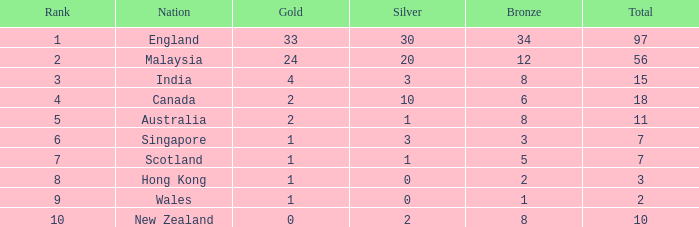Given that scotland has less than 7 medals in total, what is their tally of bronze medals? None. Would you be able to parse every entry in this table? {'header': ['Rank', 'Nation', 'Gold', 'Silver', 'Bronze', 'Total'], 'rows': [['1', 'England', '33', '30', '34', '97'], ['2', 'Malaysia', '24', '20', '12', '56'], ['3', 'India', '4', '3', '8', '15'], ['4', 'Canada', '2', '10', '6', '18'], ['5', 'Australia', '2', '1', '8', '11'], ['6', 'Singapore', '1', '3', '3', '7'], ['7', 'Scotland', '1', '1', '5', '7'], ['8', 'Hong Kong', '1', '0', '2', '3'], ['9', 'Wales', '1', '0', '1', '2'], ['10', 'New Zealand', '0', '2', '8', '10']]} 